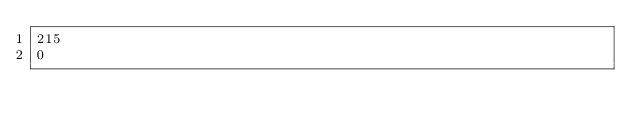Convert code to text. <code><loc_0><loc_0><loc_500><loc_500><_SQL_>215
0</code> 